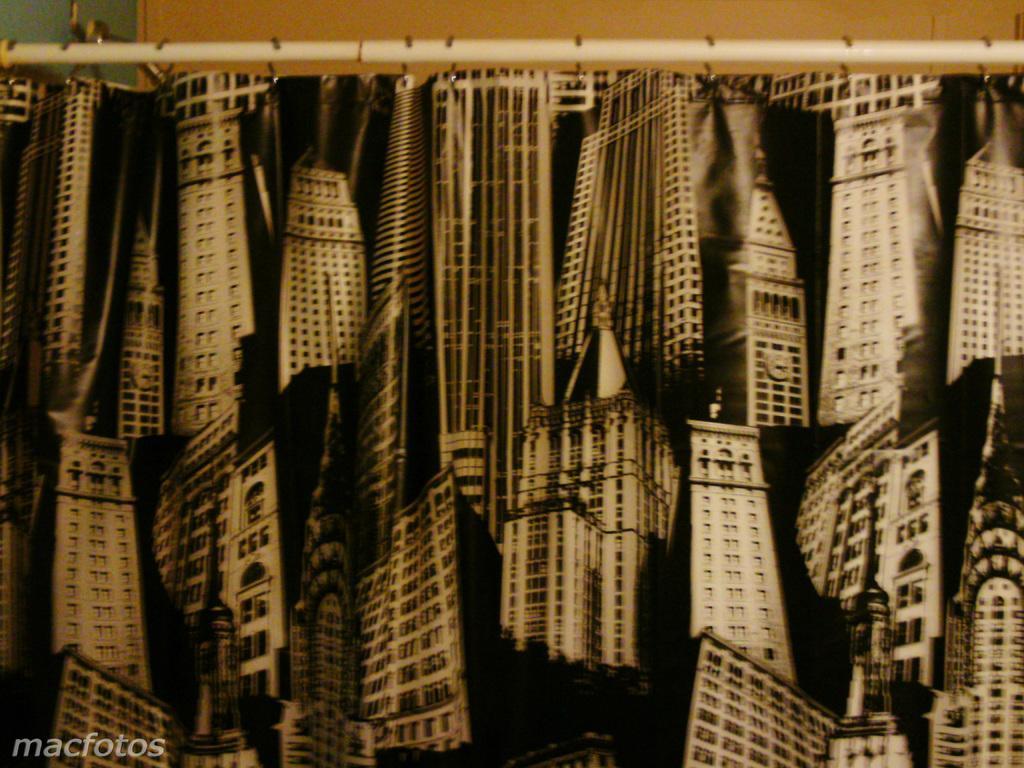Describe this image in one or two sentences. In this picture, at the top there is road and poster are attached to it. 